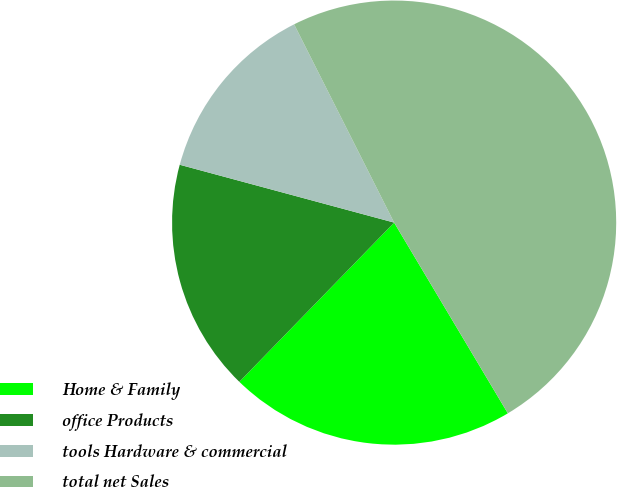<chart> <loc_0><loc_0><loc_500><loc_500><pie_chart><fcel>Home & Family<fcel>office Products<fcel>tools Hardware & commercial<fcel>total net Sales<nl><fcel>20.83%<fcel>16.92%<fcel>13.37%<fcel>48.88%<nl></chart> 